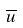<formula> <loc_0><loc_0><loc_500><loc_500>\overline { u }</formula> 